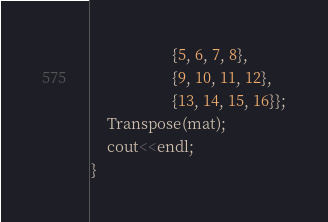<code> <loc_0><loc_0><loc_500><loc_500><_C++_>                     {5, 6, 7, 8},
                     {9, 10, 11, 12},
                     {13, 14, 15, 16}};
    Transpose(mat);
    cout<<endl;
}
</code> 